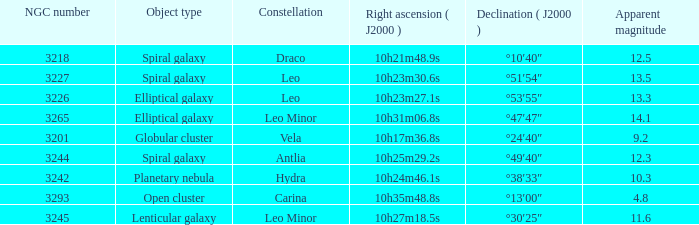What is the sum of NGC numbers for Constellation vela? 3201.0. 